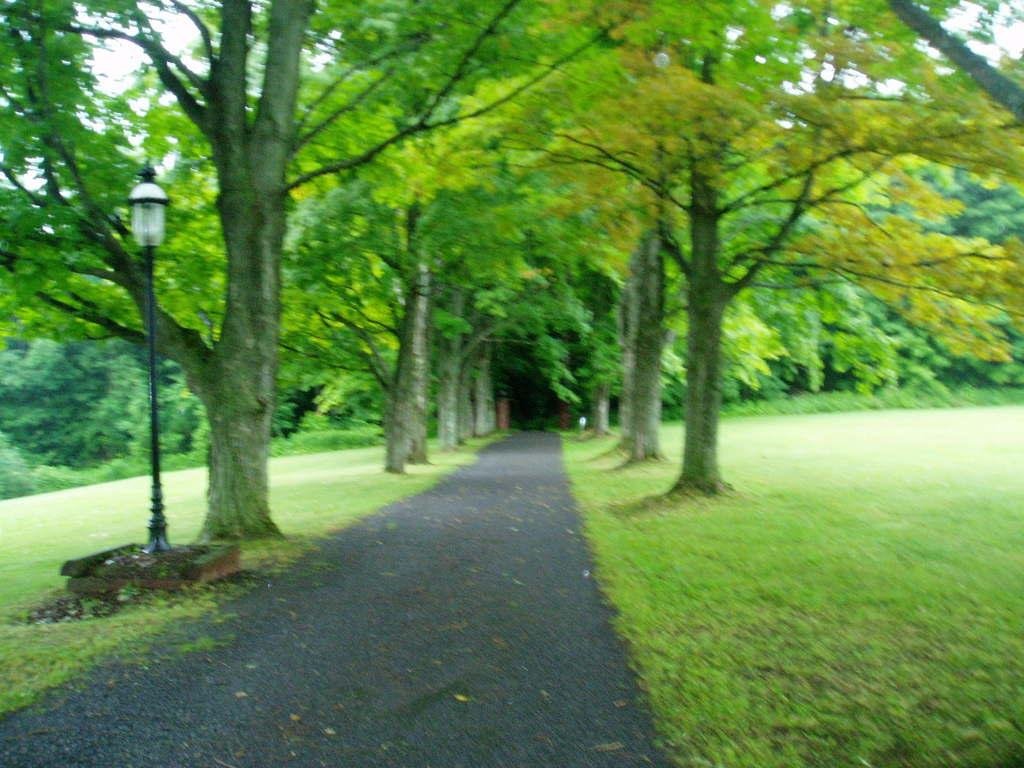What is the main feature in the middle of the image? There is a road in the middle of the image. What can be seen on either side of the road? There are trees on either side of the road. What is located on the left side of the road? There is a light pole on the left side of the road. What type of vegetation is present on the ground? There is grass on the ground. What type of robin can be seen perched on the light pole in the image? There is no robin present in the image; the light pole is the only object visible on the left side of the road. 